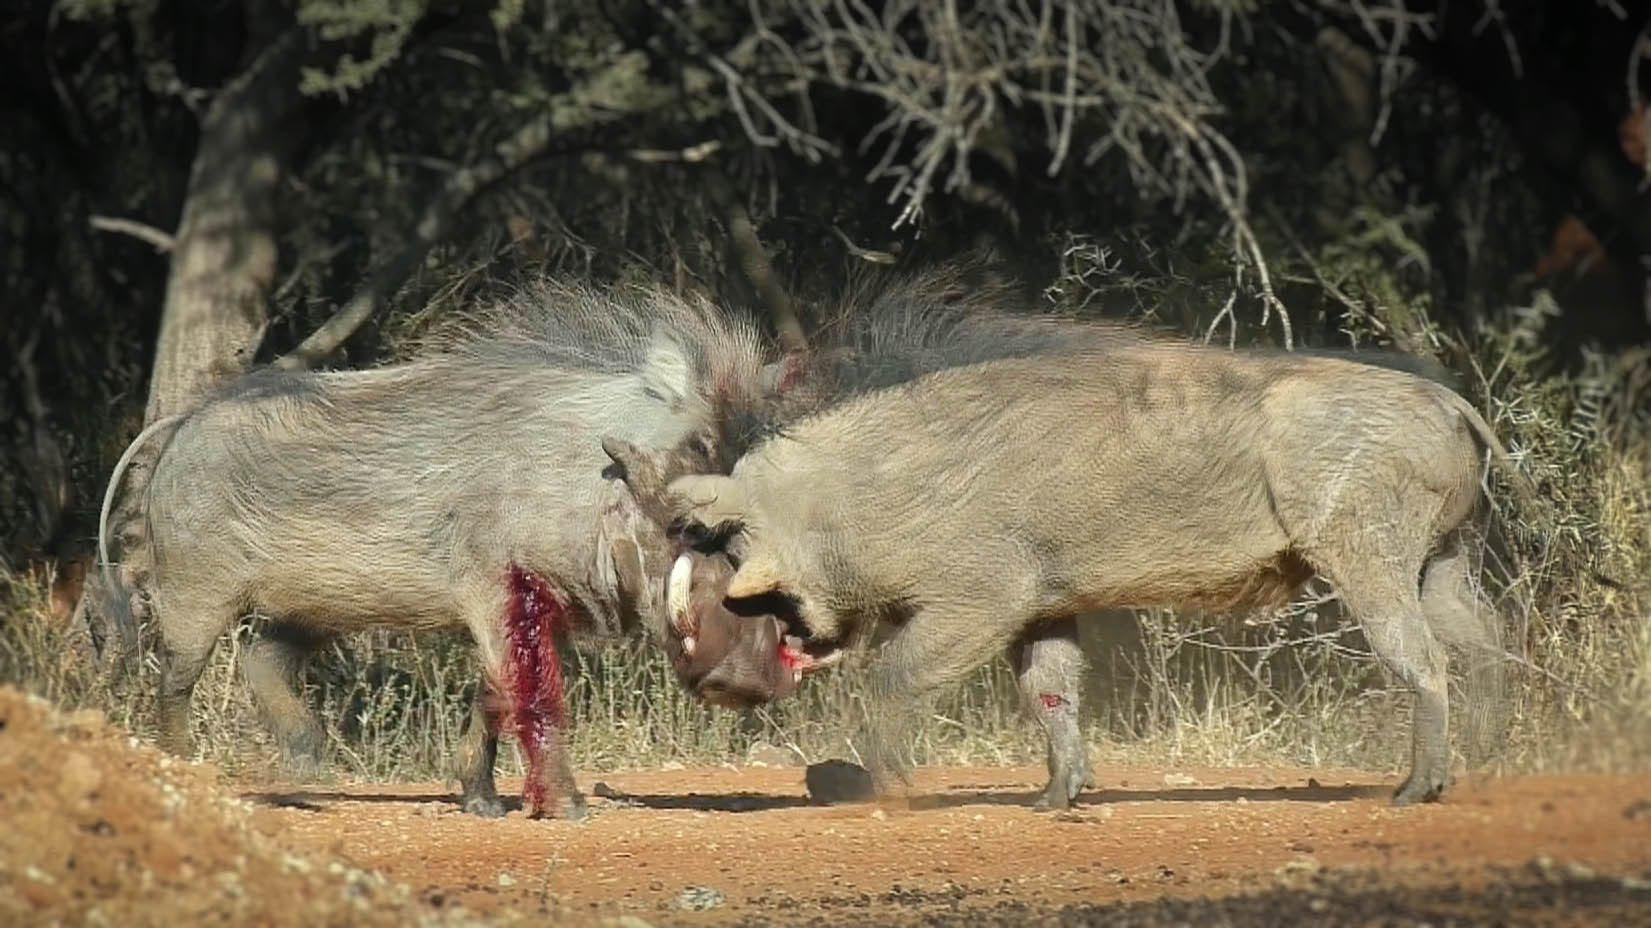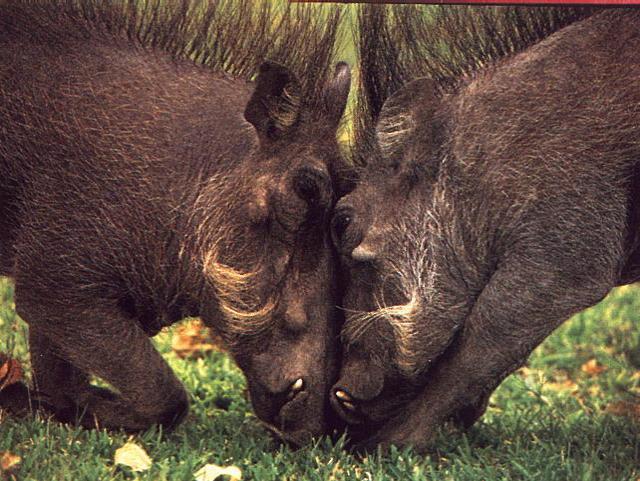The first image is the image on the left, the second image is the image on the right. For the images displayed, is the sentence "A hog's leg is bleeding while it fights another hog." factually correct? Answer yes or no. Yes. 